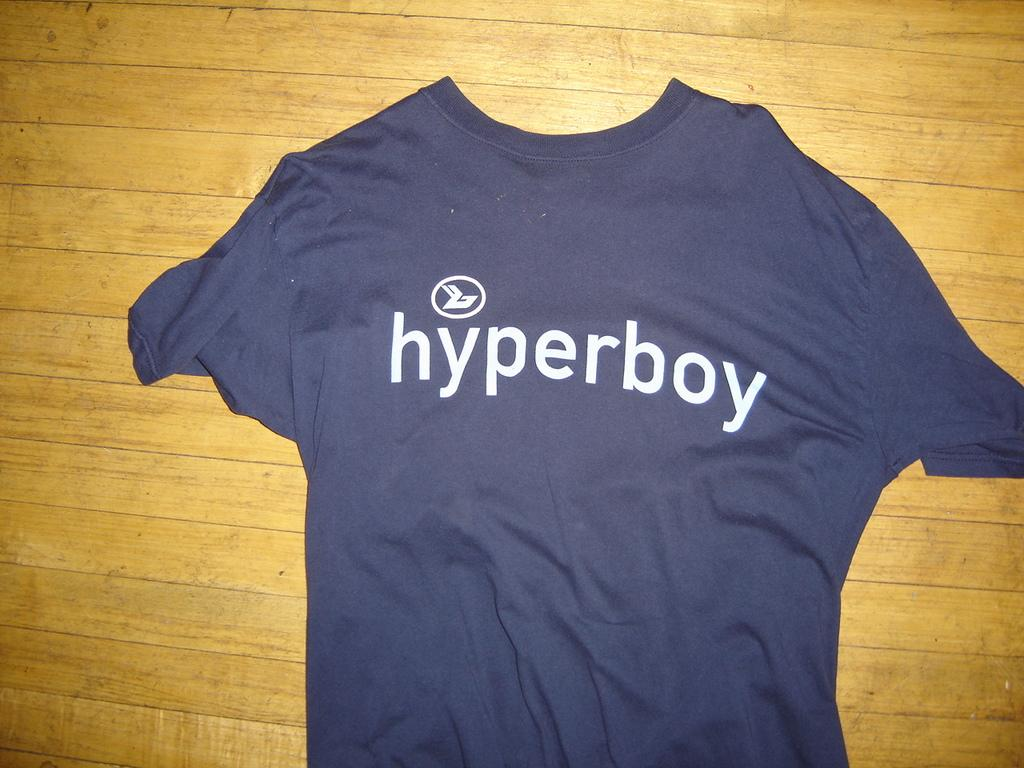<image>
Write a terse but informative summary of the picture. A small navy shirt reading hyperboy lying on a table or floor. 